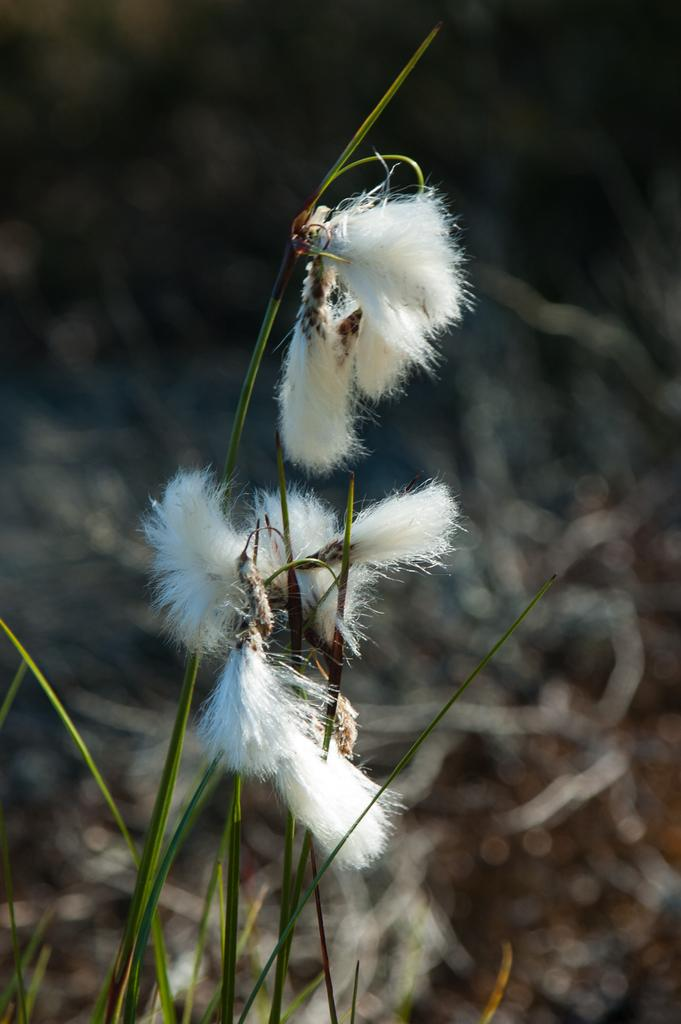What is present in the image? There is a plant in the image. What specific feature of the plant can be observed? The plant has flowers. What color are the flowers on the plant? The flowers are white in color. Can you hear the bells ringing in the image? There are no bells present in the image, so it is not possible to hear them ringing. Is there any indication of a battle taking place in the image? There is no indication of a battle or any conflict in the image; it features a plant with white flowers. 